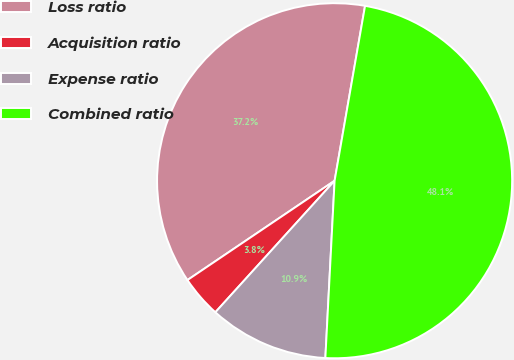Convert chart. <chart><loc_0><loc_0><loc_500><loc_500><pie_chart><fcel>Loss ratio<fcel>Acquisition ratio<fcel>Expense ratio<fcel>Combined ratio<nl><fcel>37.19%<fcel>3.83%<fcel>10.89%<fcel>48.08%<nl></chart> 